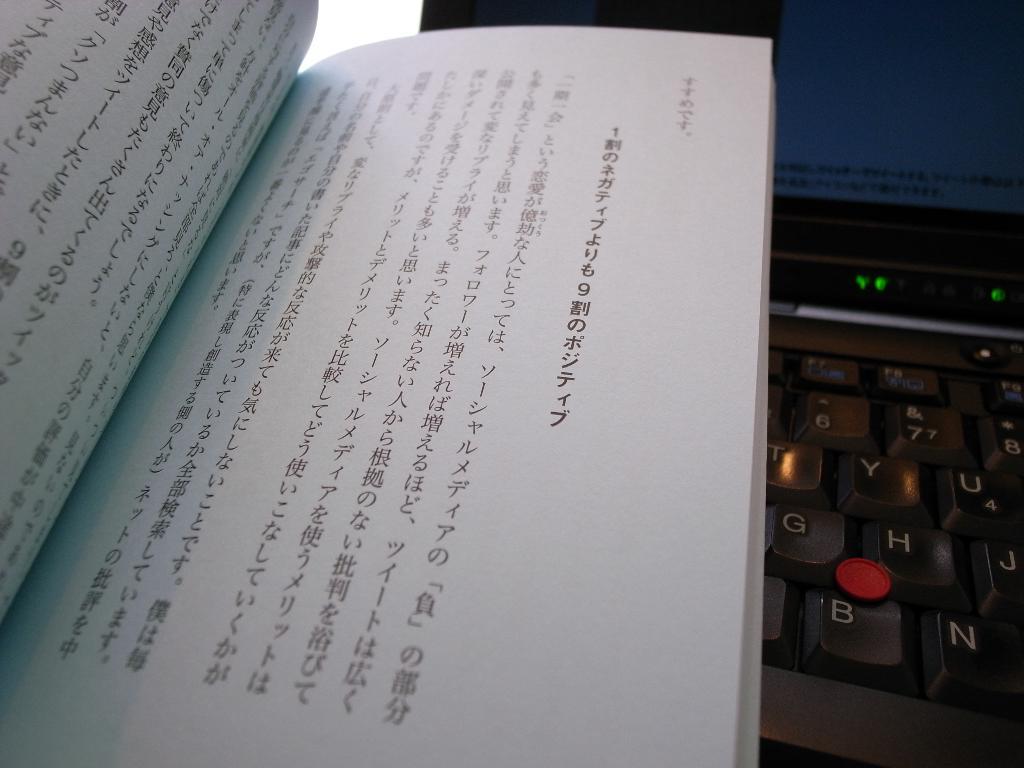Is this text in english?
Your answer should be compact. No. 